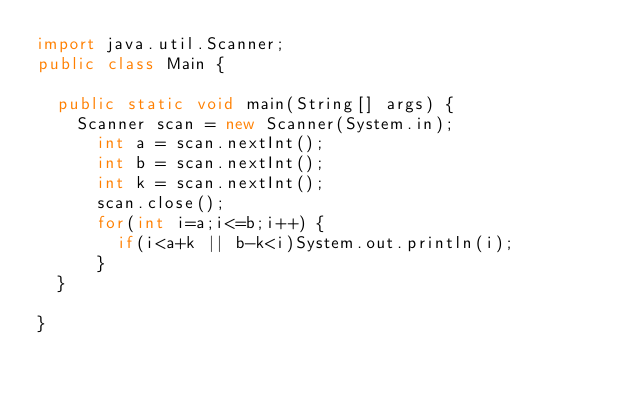Convert code to text. <code><loc_0><loc_0><loc_500><loc_500><_Java_>import java.util.Scanner;
public class Main {

	public static void main(String[] args) {
		Scanner scan = new Scanner(System.in);
	    int a = scan.nextInt();
	    int b = scan.nextInt();
	    int k = scan.nextInt();
	    scan.close();
	    for(int i=a;i<=b;i++) {
	    	if(i<a+k || b-k<i)System.out.println(i);
	    }
	}

}</code> 